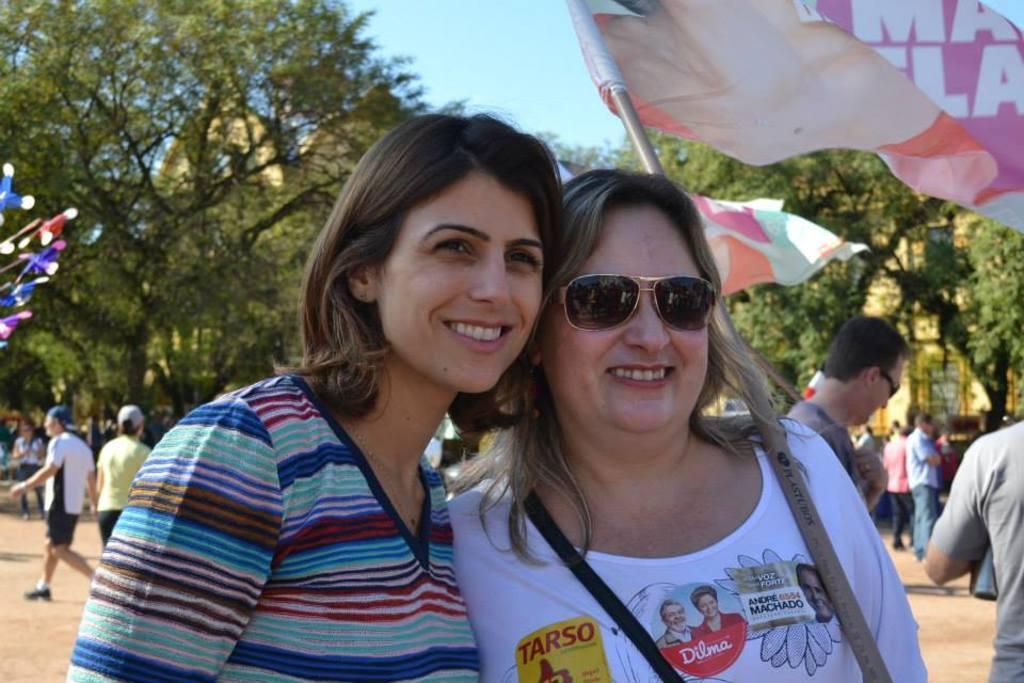How would you summarize this image in a sentence or two? This image is taken outdoors. At the top of there is the sky. In the background there are many trees and there are a few buildings. A few people are walking on the ground and a few are standing on the ground. In the middle of the image two women are standing and they are with smiling faces. There are two flags. 